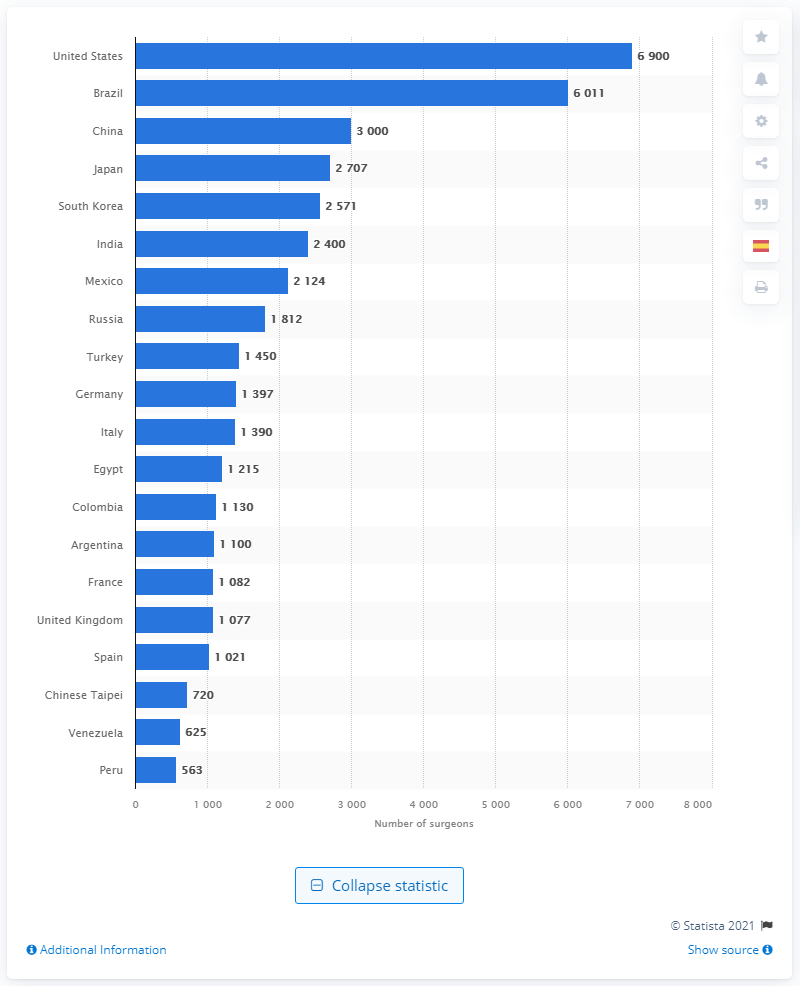Highlight a few significant elements in this photo. Brazil had the second highest number of plastic surgeons in 2019. In 2019, there were 563 plastic surgeons practicing in Peru. 